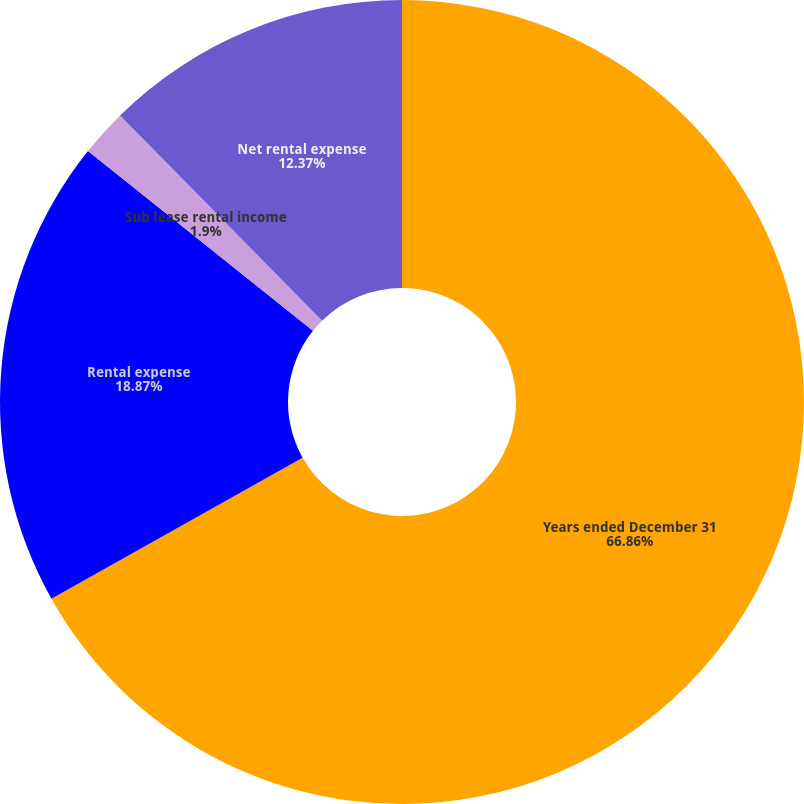<chart> <loc_0><loc_0><loc_500><loc_500><pie_chart><fcel>Years ended December 31<fcel>Rental expense<fcel>Sub lease rental income<fcel>Net rental expense<nl><fcel>66.86%<fcel>18.87%<fcel>1.9%<fcel>12.37%<nl></chart> 